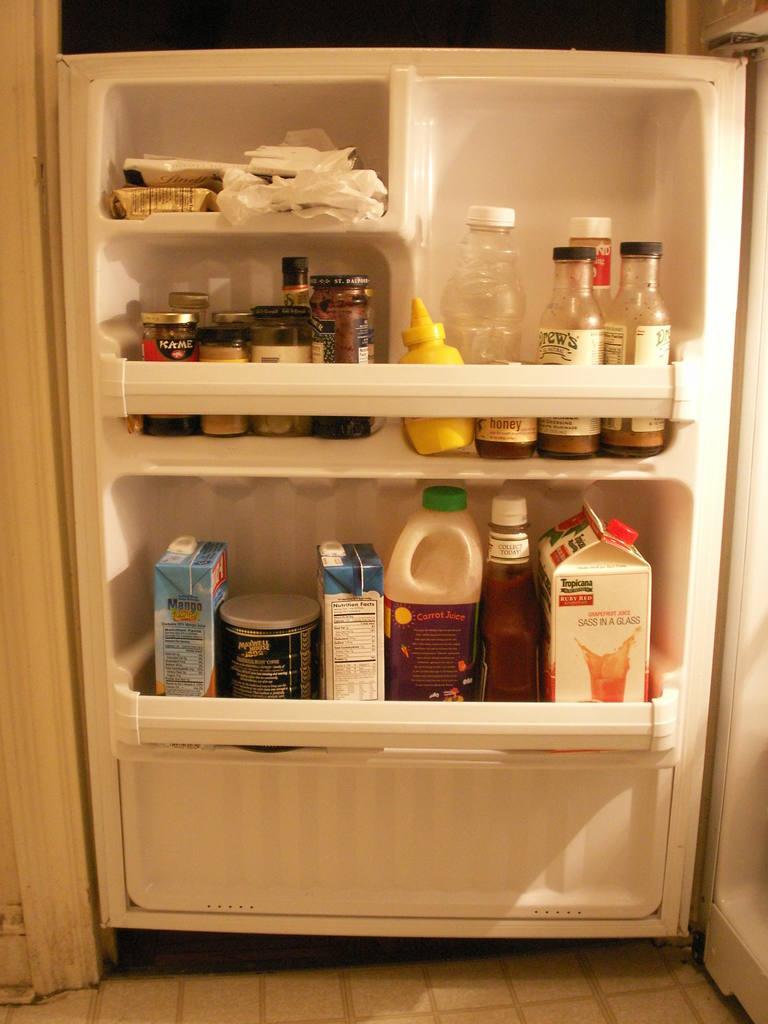What is the brand of the first jar on the left side of the second shelf?
Keep it short and to the point. Kame. Waht brand is the bottom right carton?
Give a very brief answer. Tropicana. 